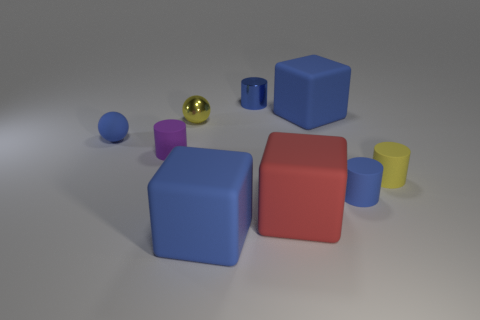What material is the other cylinder that is the same color as the small metallic cylinder?
Give a very brief answer. Rubber. There is a large red object that is the same material as the tiny yellow cylinder; what is its shape?
Your answer should be compact. Cube. Does the cylinder that is behind the small purple thing have the same size as the blue cube behind the small purple object?
Provide a short and direct response. No. Is the number of blue matte objects that are in front of the tiny metal ball greater than the number of matte spheres that are behind the small blue sphere?
Your answer should be compact. Yes. How many other objects are the same color as the tiny shiny ball?
Offer a terse response. 1. Is the color of the shiny sphere the same as the rubber thing to the right of the small blue rubber cylinder?
Keep it short and to the point. Yes. What number of red matte objects are in front of the big rubber thing that is behind the tiny purple thing?
Offer a terse response. 1. What is the big blue block behind the small blue matte thing behind the purple matte cylinder that is behind the yellow matte cylinder made of?
Ensure brevity in your answer.  Rubber. What material is the tiny cylinder that is both to the right of the small purple cylinder and on the left side of the large red rubber block?
Make the answer very short. Metal. What number of blue matte things are the same shape as the small yellow matte thing?
Offer a very short reply. 1. 